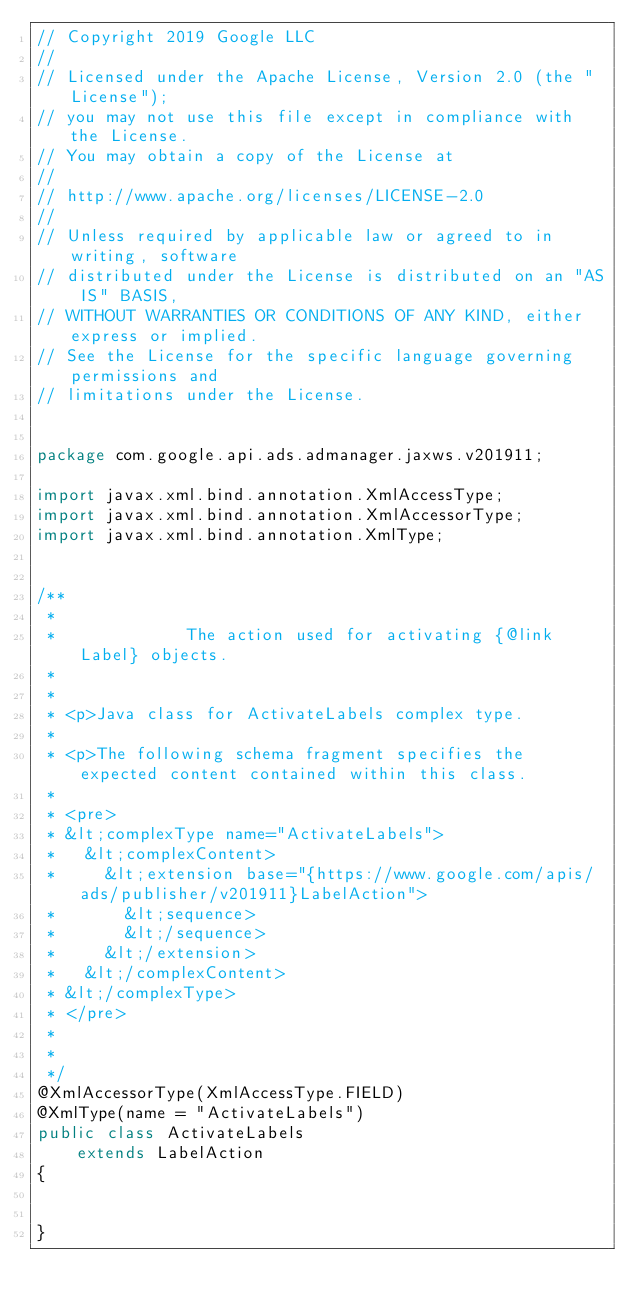Convert code to text. <code><loc_0><loc_0><loc_500><loc_500><_Java_>// Copyright 2019 Google LLC
//
// Licensed under the Apache License, Version 2.0 (the "License");
// you may not use this file except in compliance with the License.
// You may obtain a copy of the License at
//
// http://www.apache.org/licenses/LICENSE-2.0
//
// Unless required by applicable law or agreed to in writing, software
// distributed under the License is distributed on an "AS IS" BASIS,
// WITHOUT WARRANTIES OR CONDITIONS OF ANY KIND, either express or implied.
// See the License for the specific language governing permissions and
// limitations under the License.


package com.google.api.ads.admanager.jaxws.v201911;

import javax.xml.bind.annotation.XmlAccessType;
import javax.xml.bind.annotation.XmlAccessorType;
import javax.xml.bind.annotation.XmlType;


/**
 * 
 *             The action used for activating {@link Label} objects.
 *           
 * 
 * <p>Java class for ActivateLabels complex type.
 * 
 * <p>The following schema fragment specifies the expected content contained within this class.
 * 
 * <pre>
 * &lt;complexType name="ActivateLabels">
 *   &lt;complexContent>
 *     &lt;extension base="{https://www.google.com/apis/ads/publisher/v201911}LabelAction">
 *       &lt;sequence>
 *       &lt;/sequence>
 *     &lt;/extension>
 *   &lt;/complexContent>
 * &lt;/complexType>
 * </pre>
 * 
 * 
 */
@XmlAccessorType(XmlAccessType.FIELD)
@XmlType(name = "ActivateLabels")
public class ActivateLabels
    extends LabelAction
{


}
</code> 